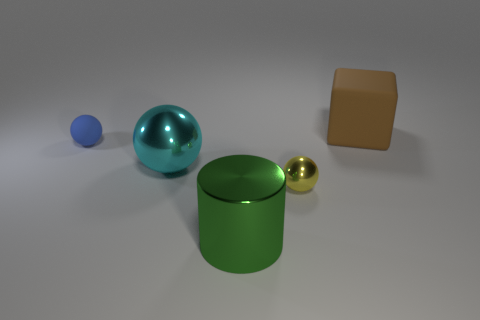There is a big object that is behind the matte object left of the big cube; is there a big cyan object that is right of it?
Provide a succinct answer. No. Does the tiny ball that is behind the cyan ball have the same material as the small thing that is in front of the blue matte thing?
Your response must be concise. No. What number of objects are metal objects or matte things left of the cyan metal sphere?
Offer a terse response. 4. How many other small metal things have the same shape as the blue thing?
Offer a very short reply. 1. What material is the brown cube that is the same size as the cyan thing?
Provide a succinct answer. Rubber. There is a matte object that is behind the matte thing that is on the left side of the rubber object right of the metal cylinder; what is its size?
Provide a short and direct response. Large. Do the rubber thing left of the brown object and the tiny sphere that is in front of the large cyan shiny object have the same color?
Ensure brevity in your answer.  No. How many cyan objects are either metallic spheres or large metal cylinders?
Offer a very short reply. 1. What number of cyan things are the same size as the cube?
Offer a very short reply. 1. Is the large thing behind the small matte sphere made of the same material as the yellow object?
Offer a very short reply. No. 